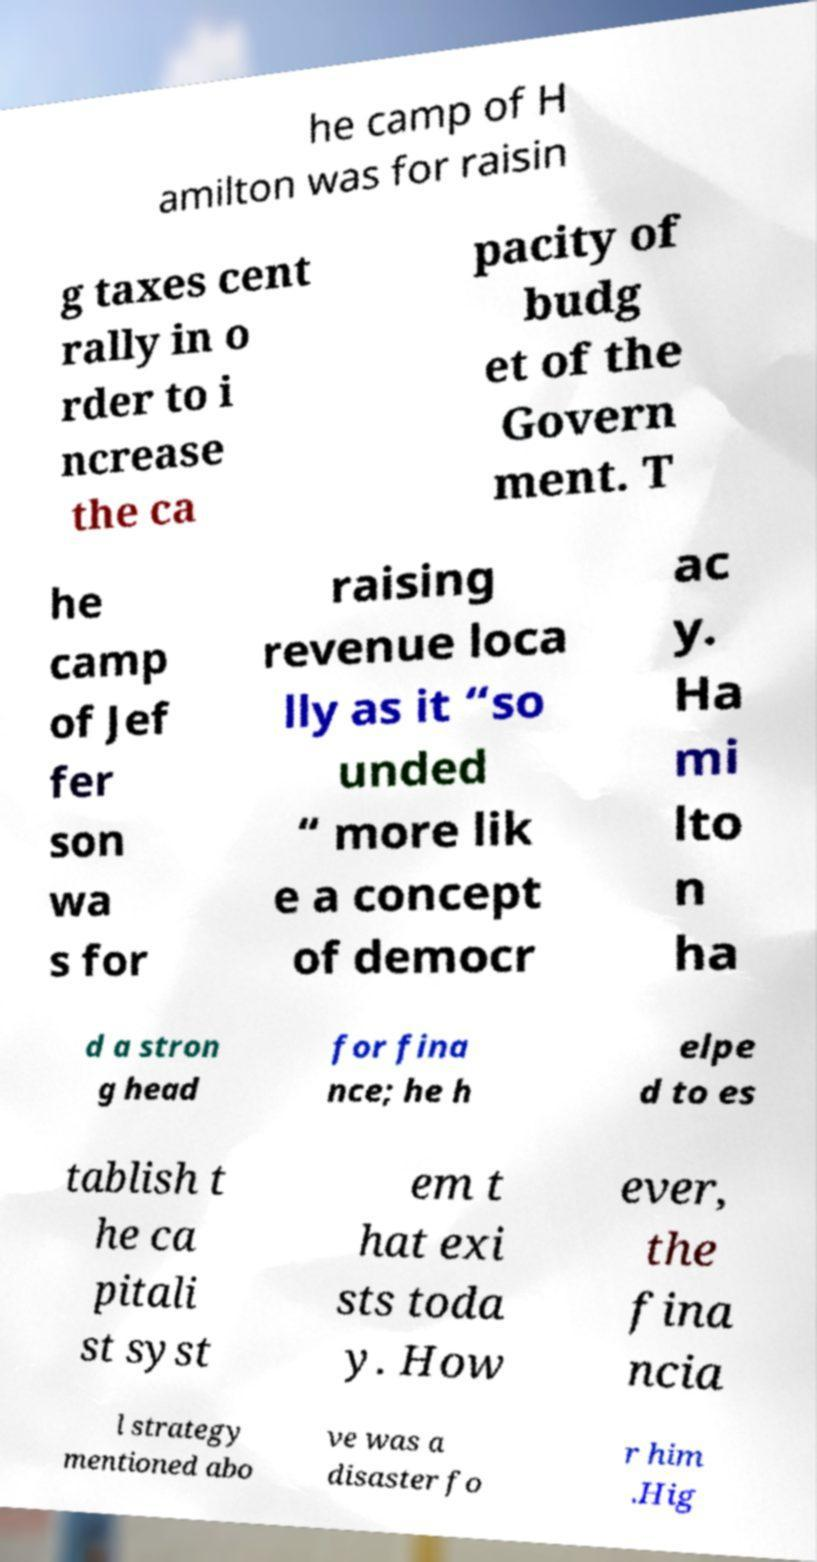Could you assist in decoding the text presented in this image and type it out clearly? he camp of H amilton was for raisin g taxes cent rally in o rder to i ncrease the ca pacity of budg et of the Govern ment. T he camp of Jef fer son wa s for raising revenue loca lly as it “so unded “ more lik e a concept of democr ac y. Ha mi lto n ha d a stron g head for fina nce; he h elpe d to es tablish t he ca pitali st syst em t hat exi sts toda y. How ever, the fina ncia l strategy mentioned abo ve was a disaster fo r him .Hig 